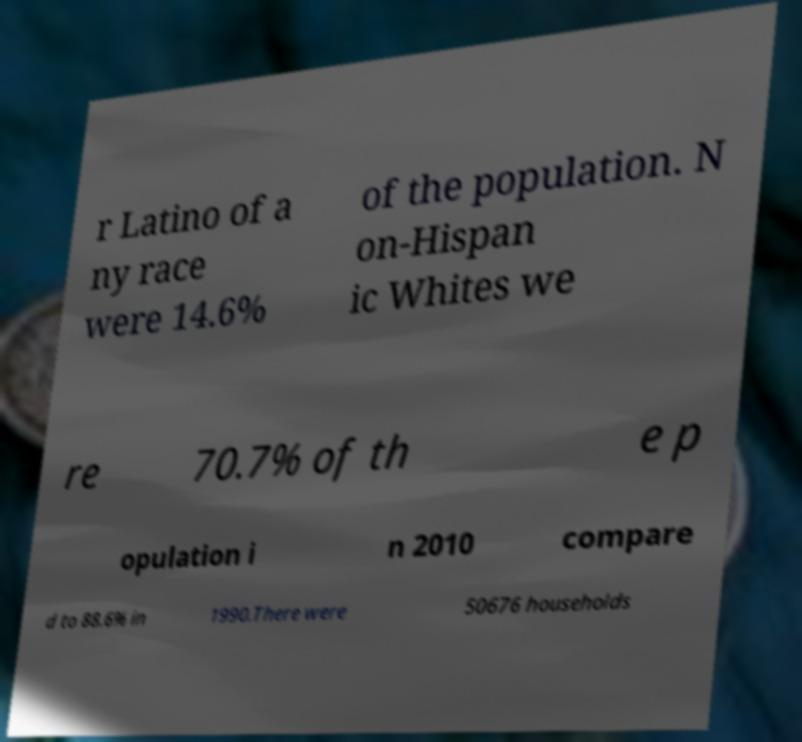Can you accurately transcribe the text from the provided image for me? r Latino of a ny race were 14.6% of the population. N on-Hispan ic Whites we re 70.7% of th e p opulation i n 2010 compare d to 88.6% in 1990.There were 50676 households 